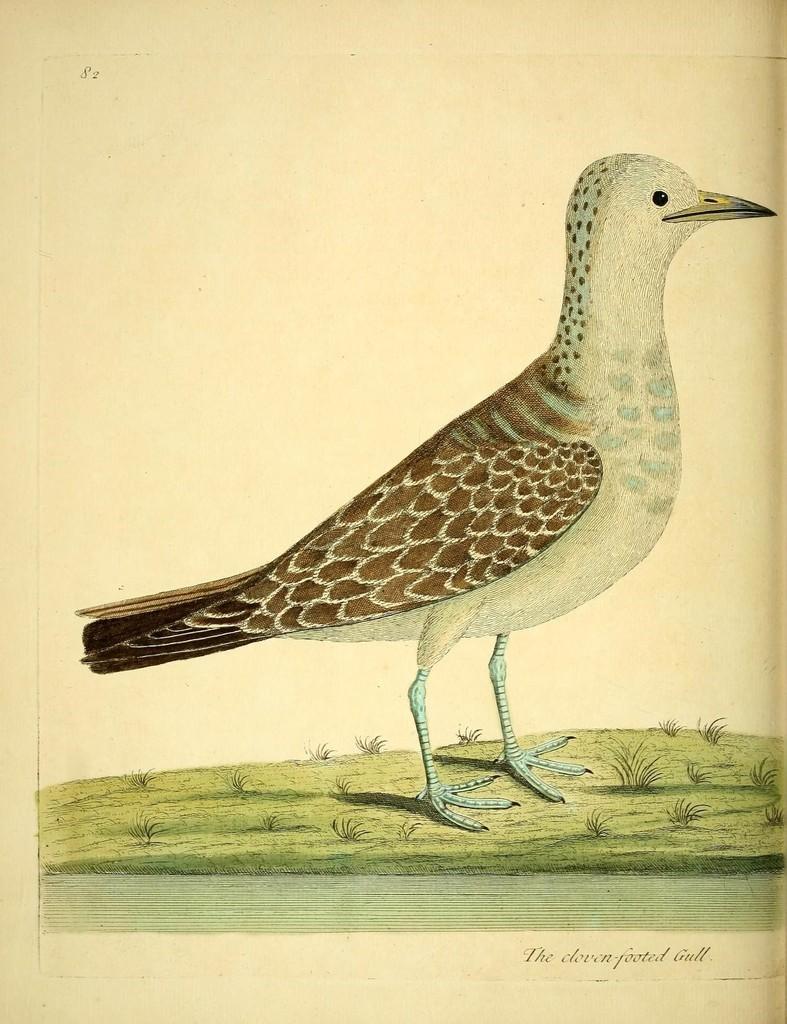Could you give a brief overview of what you see in this image? In this image I can see a poster of a bird. 